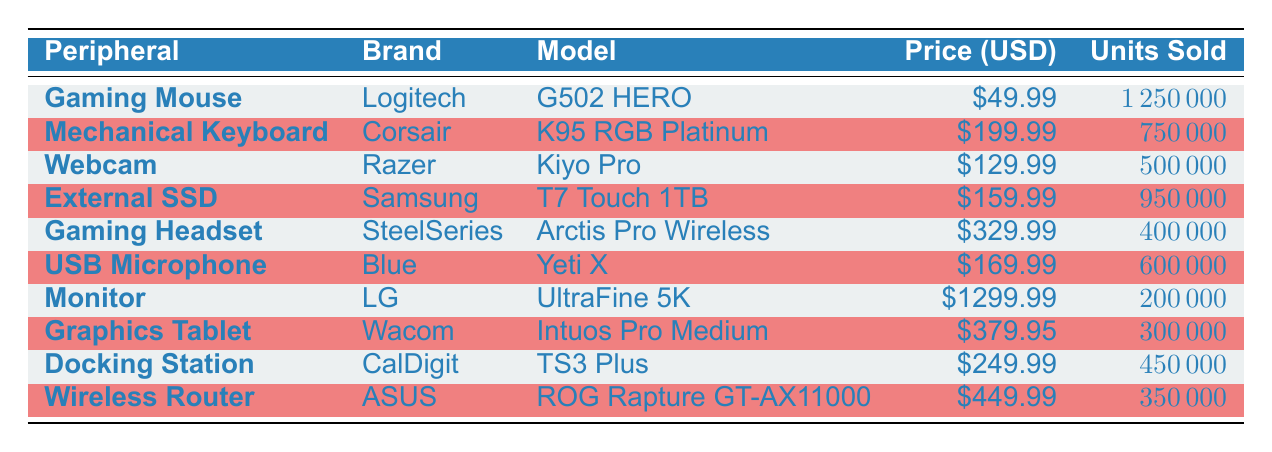What is the price of the Logitech G502 HERO gaming mouse? The price of the Logitech G502 HERO is listed in the table under the Price (USD) column beside its model, which shows 49.99.
Answer: 49.99 How many units did the Corsair K95 RGB Platinum mechanical keyboard sell? To find the figure for units sold, I checked the row for the Corsair model, which lists 750000 in the Units Sold column.
Answer: 750000 Which peripheral has the highest price? The peripheral with the highest price can be determined by comparing the Price (USD) values in the table. The LG UltraFine 5K monitor has the highest price of 1299.99.
Answer: 1299.99 What is the total number of units sold for the external SSD and the USB microphone combined? To find the total units sold for both the Samsung T7 Touch 1TB external SSD and the Blue Yeti X USB microphone, I added the units sold for each: 950000 + 600000 = 1550000.
Answer: 1550000 Is the SteelSeries Arctis Pro Wireless headset more expensive than the CalDigit TS3 Plus docking station? By comparing the prices, I can see that the SteelSeries Arctis Pro Wireless is priced at 329.99, while the CalDigit TS3 Plus is priced at 249.99. Since 329.99 is greater than 249.99, the statement is true.
Answer: Yes What is the average price of all the peripherals listed in the table? First, I need to sum the prices of all peripherals: 49.99 + 199.99 + 129.99 + 159.99 + 329.99 + 169.99 + 1299.99 + 379.95 + 249.99 + 449.99 = 3289.88. Since there are 10 items, I divide by 10: 3289.88 / 10 = 328.99.
Answer: 328.99 Did more than 1 million units sell for any peripheral? Looking at the Units Sold column, the gaming mouse sold 1250000 units, which is more than a million. Therefore, the answer is true.
Answer: Yes Which brand has the least expensive peripheral in this table? By checking the Price (USD) values, I see that the Logitech G502 HERO has the least expensive price of 49.99, making Logitech the brand for the cheapest peripheral.
Answer: Logitech 